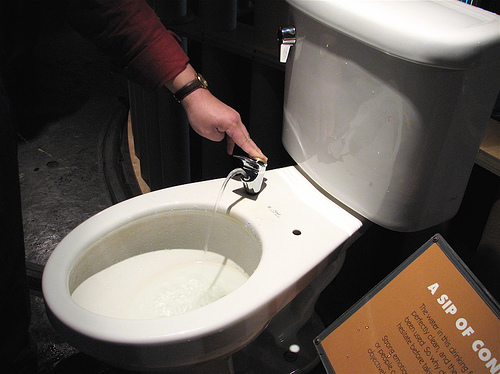Read and extract the text from this image. SIP A OF CON 